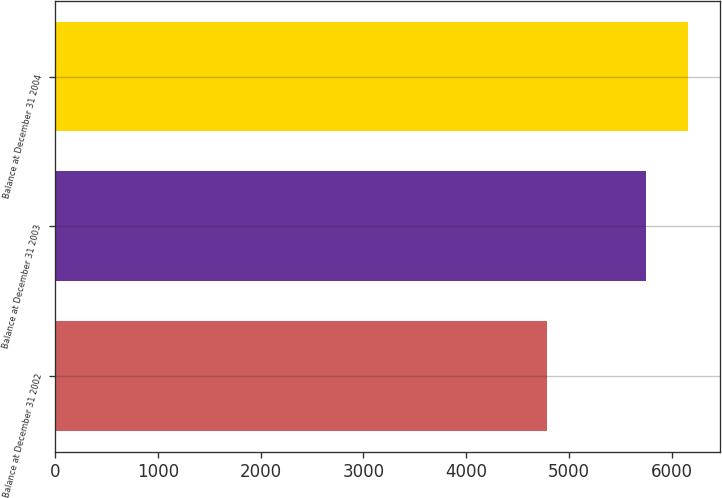Convert chart. <chart><loc_0><loc_0><loc_500><loc_500><bar_chart><fcel>Balance at December 31 2002<fcel>Balance at December 31 2003<fcel>Balance at December 31 2004<nl><fcel>4787<fcel>5747<fcel>6159<nl></chart> 